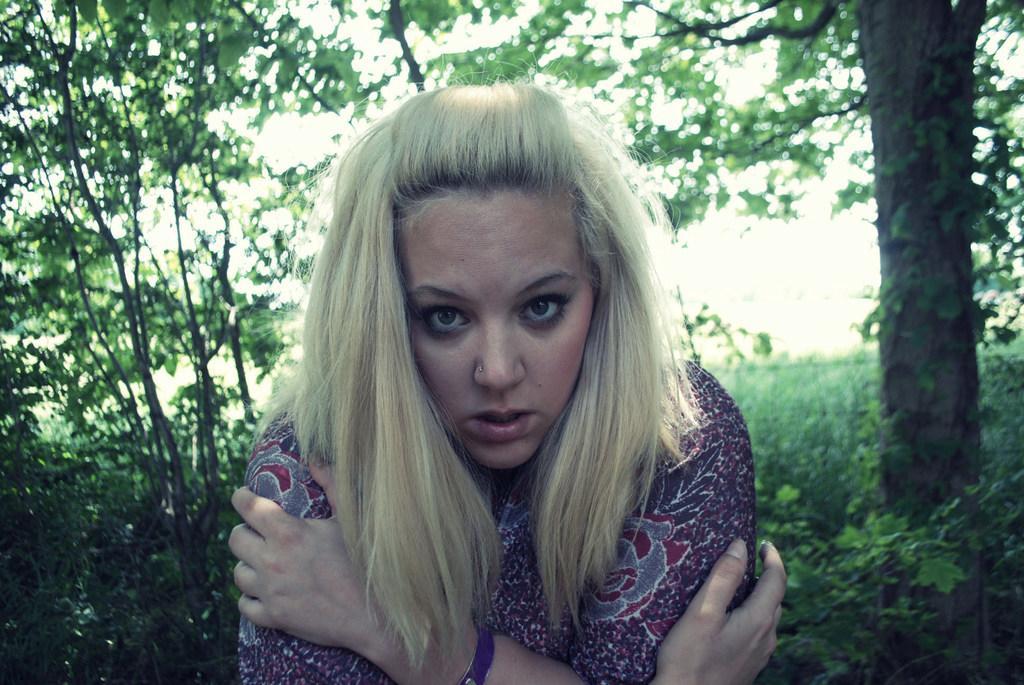How would you summarize this image in a sentence or two? In this image we can see a person and there are few plants and trees in the background. 